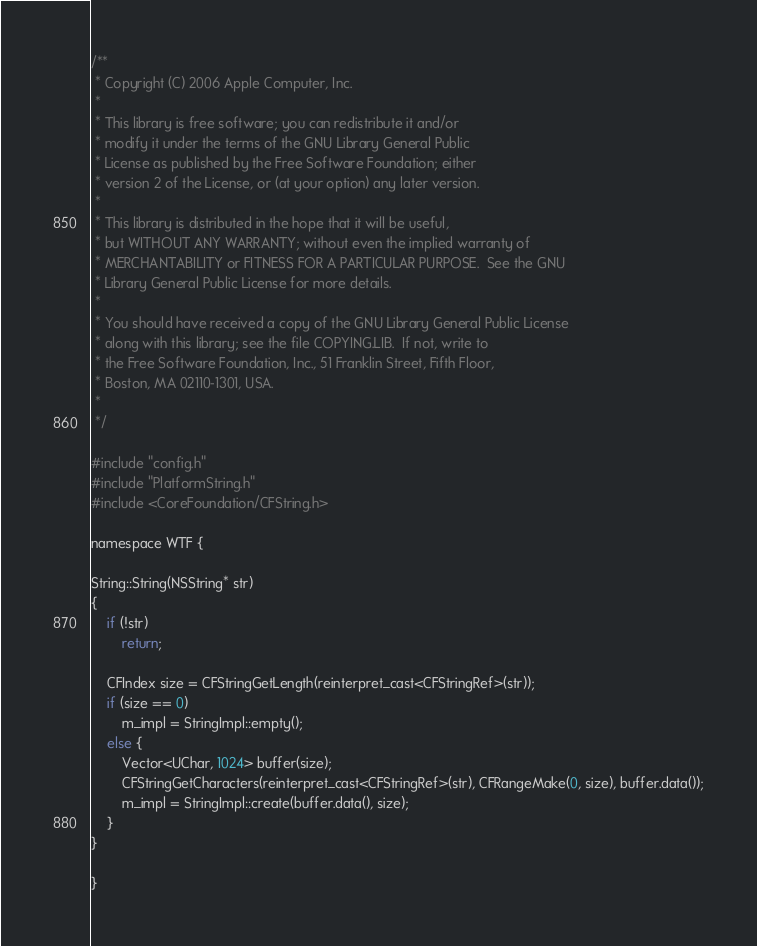<code> <loc_0><loc_0><loc_500><loc_500><_ObjectiveC_>/**
 * Copyright (C) 2006 Apple Computer, Inc.
 *
 * This library is free software; you can redistribute it and/or
 * modify it under the terms of the GNU Library General Public
 * License as published by the Free Software Foundation; either
 * version 2 of the License, or (at your option) any later version.
 *
 * This library is distributed in the hope that it will be useful,
 * but WITHOUT ANY WARRANTY; without even the implied warranty of
 * MERCHANTABILITY or FITNESS FOR A PARTICULAR PURPOSE.  See the GNU
 * Library General Public License for more details.
 *
 * You should have received a copy of the GNU Library General Public License
 * along with this library; see the file COPYING.LIB.  If not, write to
 * the Free Software Foundation, Inc., 51 Franklin Street, Fifth Floor,
 * Boston, MA 02110-1301, USA.
 *
 */

#include "config.h"
#include "PlatformString.h"
#include <CoreFoundation/CFString.h>

namespace WTF {

String::String(NSString* str)
{
    if (!str)
        return;

    CFIndex size = CFStringGetLength(reinterpret_cast<CFStringRef>(str));
    if (size == 0)
        m_impl = StringImpl::empty();
    else {
        Vector<UChar, 1024> buffer(size);
        CFStringGetCharacters(reinterpret_cast<CFStringRef>(str), CFRangeMake(0, size), buffer.data());
        m_impl = StringImpl::create(buffer.data(), size);
    }
}

}
</code> 